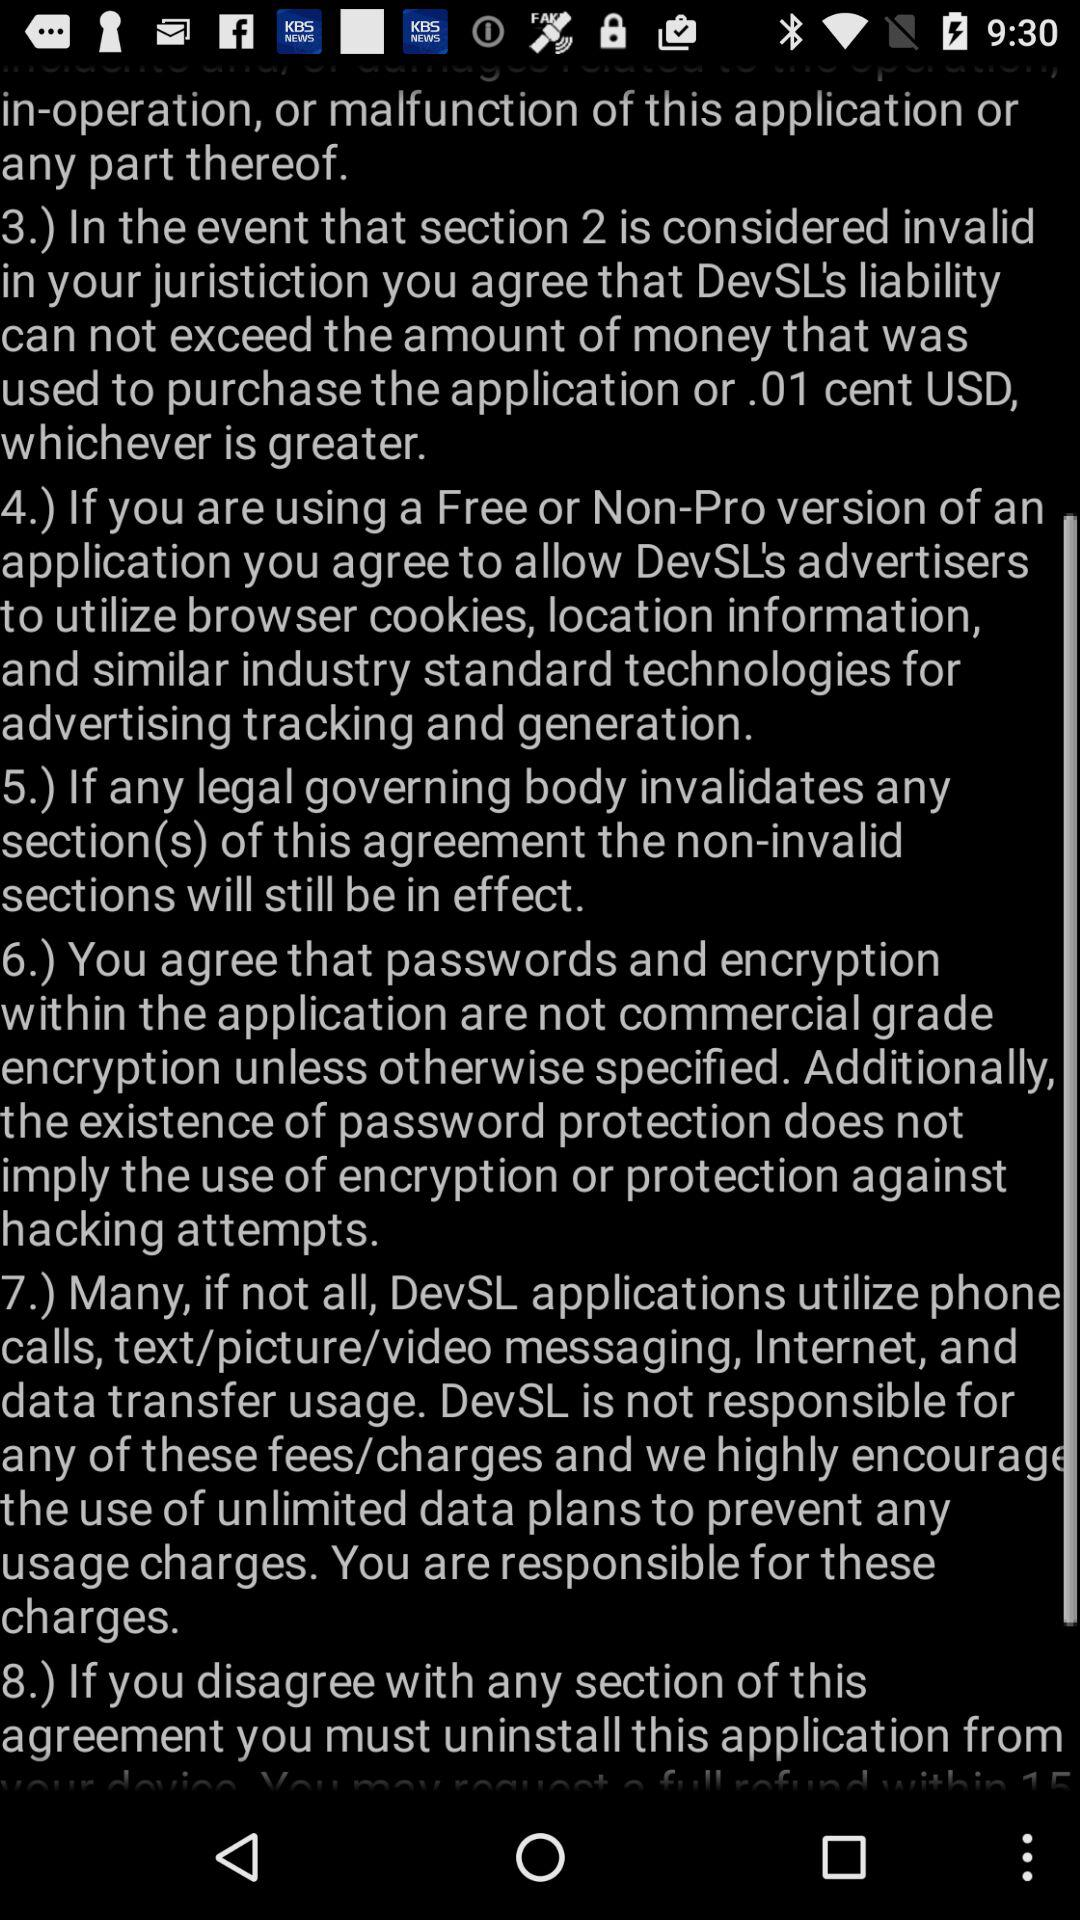How many sections are there in this agreement? Based on the visible text, there appear to be at least six sections in this agreement, as indicated by the numerals followed by a right parenthesis. However, without seeing the entire document it's impossible to provide a definitive total count. Typically, an agreement would have sections that are clearly numbered to delineate distinct topics or terms. 